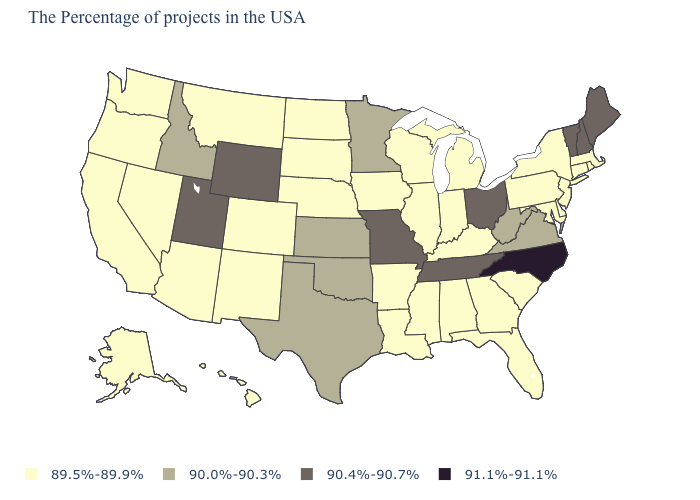Does Oklahoma have the lowest value in the South?
Give a very brief answer. No. Does Virginia have the same value as Minnesota?
Be succinct. Yes. What is the value of New Jersey?
Short answer required. 89.5%-89.9%. Does New York have the highest value in the Northeast?
Be succinct. No. Which states have the highest value in the USA?
Be succinct. North Carolina. Among the states that border Michigan , does Ohio have the highest value?
Keep it brief. Yes. What is the value of Massachusetts?
Quick response, please. 89.5%-89.9%. What is the lowest value in the MidWest?
Write a very short answer. 89.5%-89.9%. What is the value of Maine?
Answer briefly. 90.4%-90.7%. What is the lowest value in states that border Vermont?
Write a very short answer. 89.5%-89.9%. Name the states that have a value in the range 90.0%-90.3%?
Quick response, please. Virginia, West Virginia, Minnesota, Kansas, Oklahoma, Texas, Idaho. Name the states that have a value in the range 90.0%-90.3%?
Write a very short answer. Virginia, West Virginia, Minnesota, Kansas, Oklahoma, Texas, Idaho. Does New Hampshire have the highest value in the Northeast?
Keep it brief. Yes. 